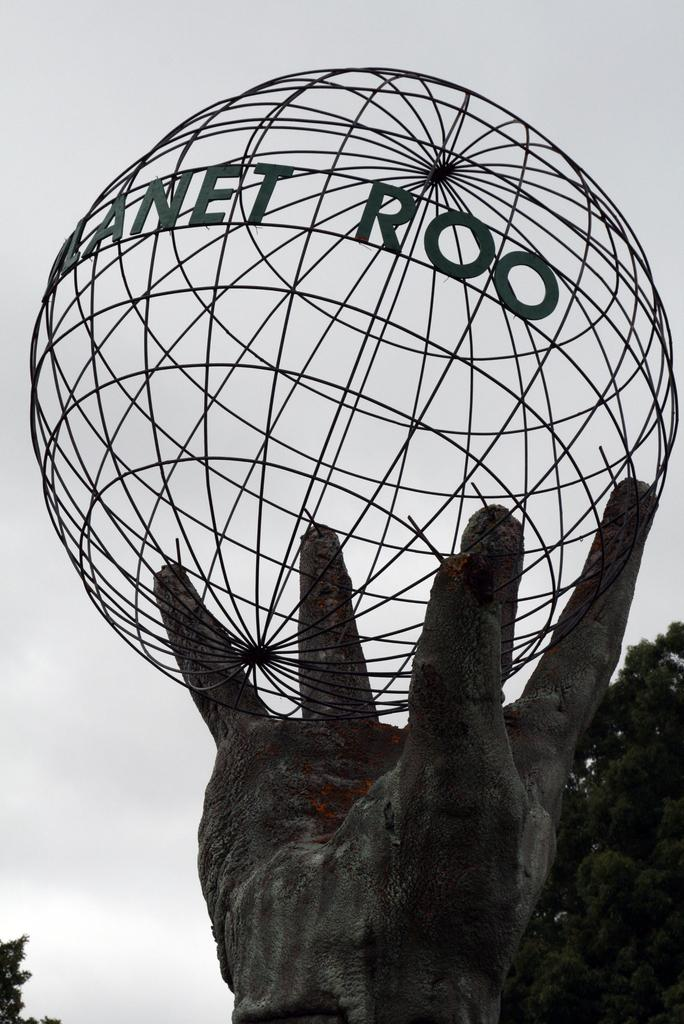What is the main subject of the image? The main subject of the image is a sculpture of a hand holding a globe. Can you describe the sculpture in more detail? The sculpture features a hand holding a globe. What can be seen in the background of the image? There are trees visible behind the sculpture. How many chairs are placed around the brass cellar in the image? There are no chairs or brass cellars present in the image; it features a sculpture of a hand holding a globe with trees in the background. 